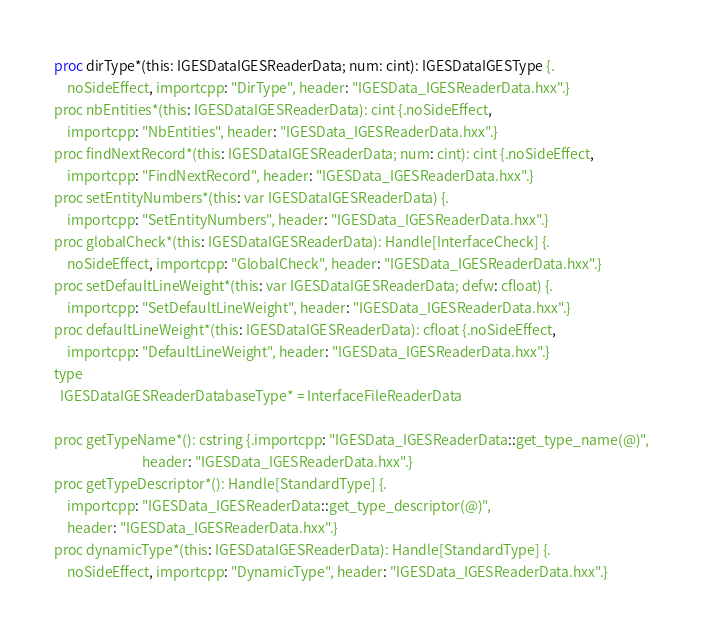<code> <loc_0><loc_0><loc_500><loc_500><_Nim_>proc dirType*(this: IGESDataIGESReaderData; num: cint): IGESDataIGESType {.
    noSideEffect, importcpp: "DirType", header: "IGESData_IGESReaderData.hxx".}
proc nbEntities*(this: IGESDataIGESReaderData): cint {.noSideEffect,
    importcpp: "NbEntities", header: "IGESData_IGESReaderData.hxx".}
proc findNextRecord*(this: IGESDataIGESReaderData; num: cint): cint {.noSideEffect,
    importcpp: "FindNextRecord", header: "IGESData_IGESReaderData.hxx".}
proc setEntityNumbers*(this: var IGESDataIGESReaderData) {.
    importcpp: "SetEntityNumbers", header: "IGESData_IGESReaderData.hxx".}
proc globalCheck*(this: IGESDataIGESReaderData): Handle[InterfaceCheck] {.
    noSideEffect, importcpp: "GlobalCheck", header: "IGESData_IGESReaderData.hxx".}
proc setDefaultLineWeight*(this: var IGESDataIGESReaderData; defw: cfloat) {.
    importcpp: "SetDefaultLineWeight", header: "IGESData_IGESReaderData.hxx".}
proc defaultLineWeight*(this: IGESDataIGESReaderData): cfloat {.noSideEffect,
    importcpp: "DefaultLineWeight", header: "IGESData_IGESReaderData.hxx".}
type
  IGESDataIGESReaderDatabaseType* = InterfaceFileReaderData

proc getTypeName*(): cstring {.importcpp: "IGESData_IGESReaderData::get_type_name(@)",
                            header: "IGESData_IGESReaderData.hxx".}
proc getTypeDescriptor*(): Handle[StandardType] {.
    importcpp: "IGESData_IGESReaderData::get_type_descriptor(@)",
    header: "IGESData_IGESReaderData.hxx".}
proc dynamicType*(this: IGESDataIGESReaderData): Handle[StandardType] {.
    noSideEffect, importcpp: "DynamicType", header: "IGESData_IGESReaderData.hxx".}

























</code> 